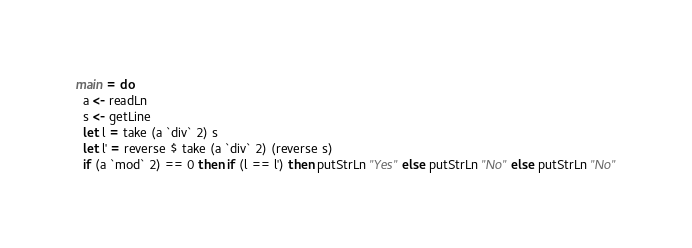Convert code to text. <code><loc_0><loc_0><loc_500><loc_500><_Haskell_>main = do 
  a <- readLn
  s <- getLine
  let l = take (a `div` 2) s
  let l' = reverse $ take (a `div` 2) (reverse s)
  if (a `mod` 2) == 0 then if (l == l') then putStrLn "Yes" else putStrLn "No" else putStrLn "No"</code> 